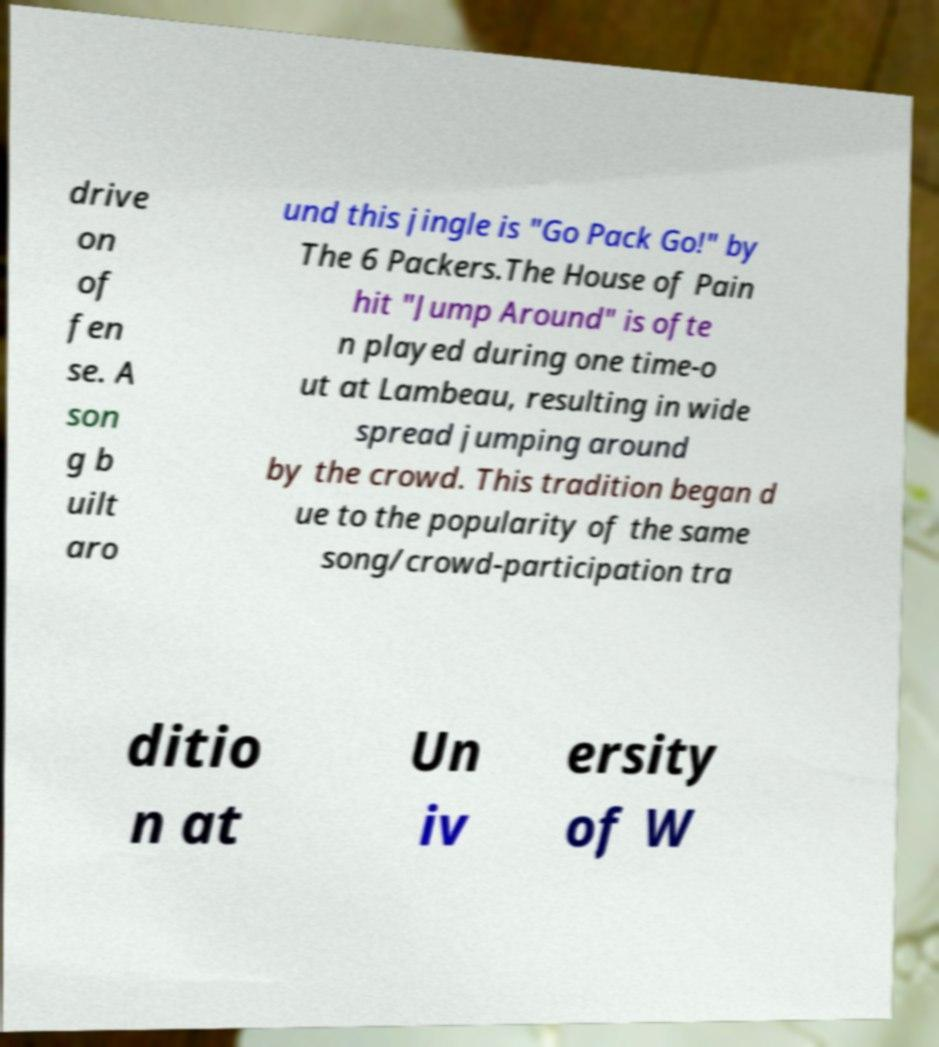Could you assist in decoding the text presented in this image and type it out clearly? drive on of fen se. A son g b uilt aro und this jingle is "Go Pack Go!" by The 6 Packers.The House of Pain hit "Jump Around" is ofte n played during one time-o ut at Lambeau, resulting in wide spread jumping around by the crowd. This tradition began d ue to the popularity of the same song/crowd-participation tra ditio n at Un iv ersity of W 